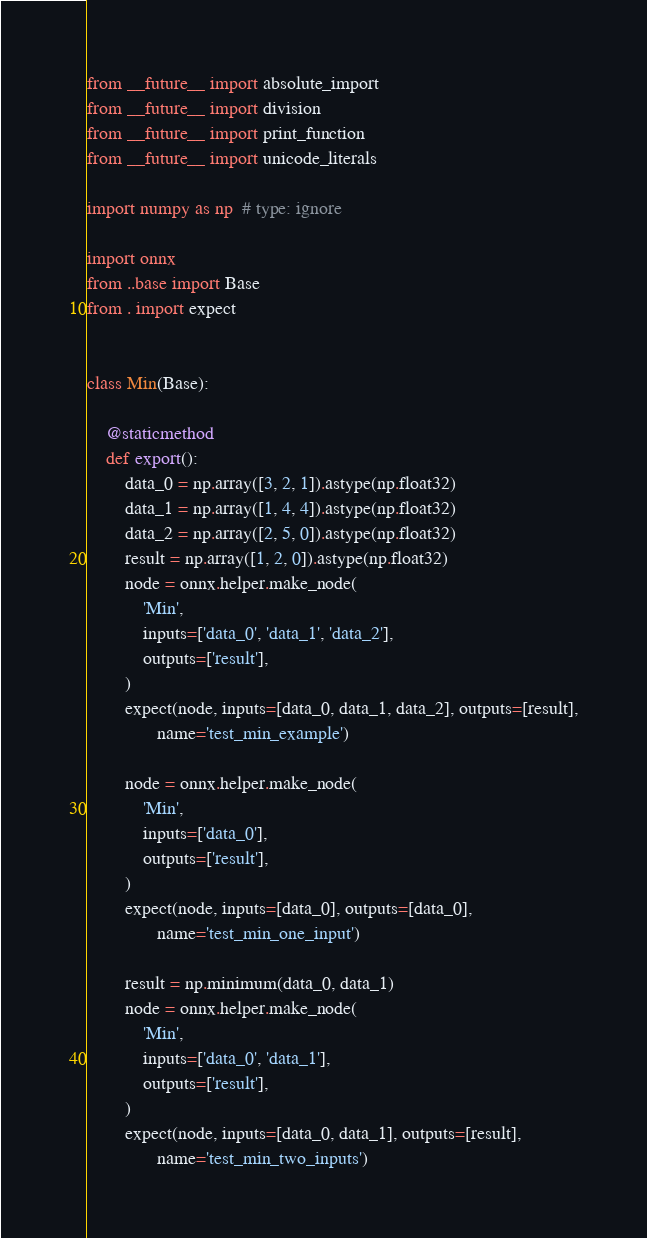Convert code to text. <code><loc_0><loc_0><loc_500><loc_500><_Python_>from __future__ import absolute_import
from __future__ import division
from __future__ import print_function
from __future__ import unicode_literals

import numpy as np  # type: ignore

import onnx
from ..base import Base
from . import expect


class Min(Base):

    @staticmethod
    def export():
        data_0 = np.array([3, 2, 1]).astype(np.float32)
        data_1 = np.array([1, 4, 4]).astype(np.float32)
        data_2 = np.array([2, 5, 0]).astype(np.float32)
        result = np.array([1, 2, 0]).astype(np.float32)
        node = onnx.helper.make_node(
            'Min',
            inputs=['data_0', 'data_1', 'data_2'],
            outputs=['result'],
        )
        expect(node, inputs=[data_0, data_1, data_2], outputs=[result],
               name='test_min_example')

        node = onnx.helper.make_node(
            'Min',
            inputs=['data_0'],
            outputs=['result'],
        )
        expect(node, inputs=[data_0], outputs=[data_0],
               name='test_min_one_input')

        result = np.minimum(data_0, data_1)
        node = onnx.helper.make_node(
            'Min',
            inputs=['data_0', 'data_1'],
            outputs=['result'],
        )
        expect(node, inputs=[data_0, data_1], outputs=[result],
               name='test_min_two_inputs')
</code> 